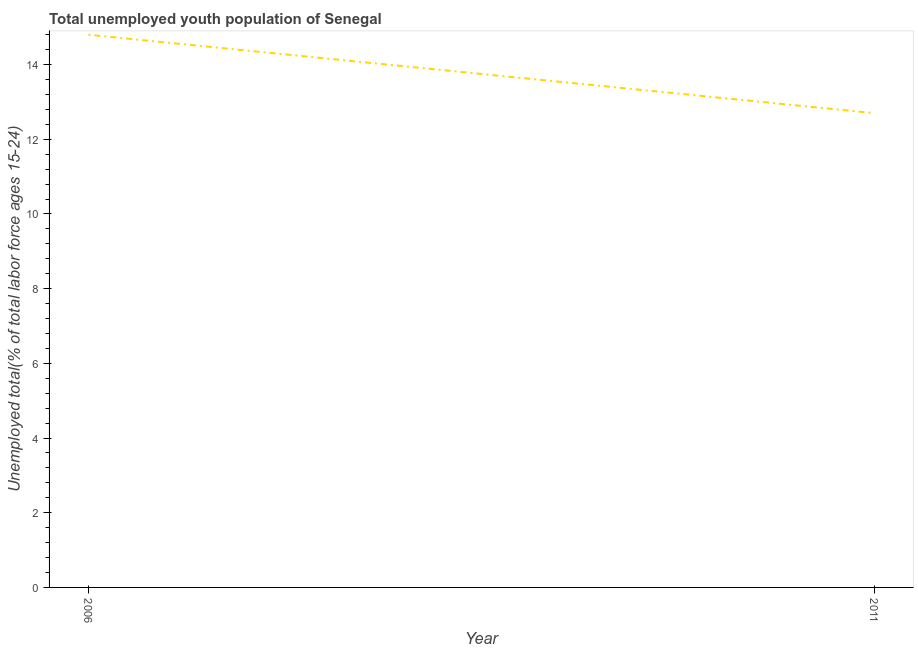What is the unemployed youth in 2006?
Give a very brief answer. 14.8. Across all years, what is the maximum unemployed youth?
Provide a succinct answer. 14.8. Across all years, what is the minimum unemployed youth?
Your response must be concise. 12.7. In which year was the unemployed youth maximum?
Keep it short and to the point. 2006. In which year was the unemployed youth minimum?
Make the answer very short. 2011. What is the difference between the unemployed youth in 2006 and 2011?
Make the answer very short. 2.1. What is the average unemployed youth per year?
Your answer should be compact. 13.75. What is the median unemployed youth?
Your response must be concise. 13.75. Do a majority of the years between 2006 and 2011 (inclusive) have unemployed youth greater than 3.2 %?
Give a very brief answer. Yes. What is the ratio of the unemployed youth in 2006 to that in 2011?
Give a very brief answer. 1.17. Is the unemployed youth in 2006 less than that in 2011?
Ensure brevity in your answer.  No. How many lines are there?
Your answer should be compact. 1. What is the difference between two consecutive major ticks on the Y-axis?
Offer a very short reply. 2. Are the values on the major ticks of Y-axis written in scientific E-notation?
Provide a short and direct response. No. Does the graph contain any zero values?
Provide a short and direct response. No. What is the title of the graph?
Provide a short and direct response. Total unemployed youth population of Senegal. What is the label or title of the Y-axis?
Give a very brief answer. Unemployed total(% of total labor force ages 15-24). What is the Unemployed total(% of total labor force ages 15-24) in 2006?
Keep it short and to the point. 14.8. What is the Unemployed total(% of total labor force ages 15-24) in 2011?
Keep it short and to the point. 12.7. What is the difference between the Unemployed total(% of total labor force ages 15-24) in 2006 and 2011?
Ensure brevity in your answer.  2.1. What is the ratio of the Unemployed total(% of total labor force ages 15-24) in 2006 to that in 2011?
Your answer should be compact. 1.17. 